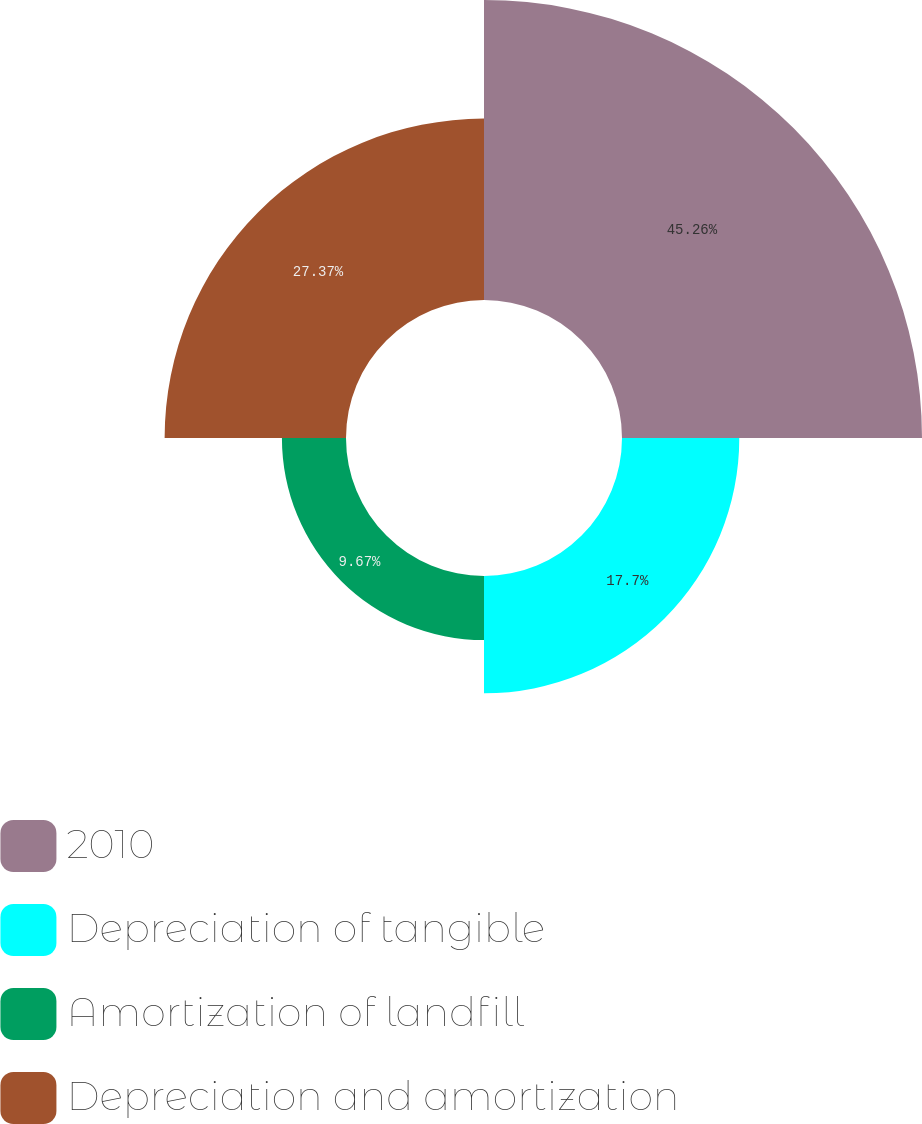<chart> <loc_0><loc_0><loc_500><loc_500><pie_chart><fcel>2010<fcel>Depreciation of tangible<fcel>Amortization of landfill<fcel>Depreciation and amortization<nl><fcel>45.27%<fcel>17.7%<fcel>9.67%<fcel>27.37%<nl></chart> 